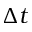Convert formula to latex. <formula><loc_0><loc_0><loc_500><loc_500>\Delta t</formula> 